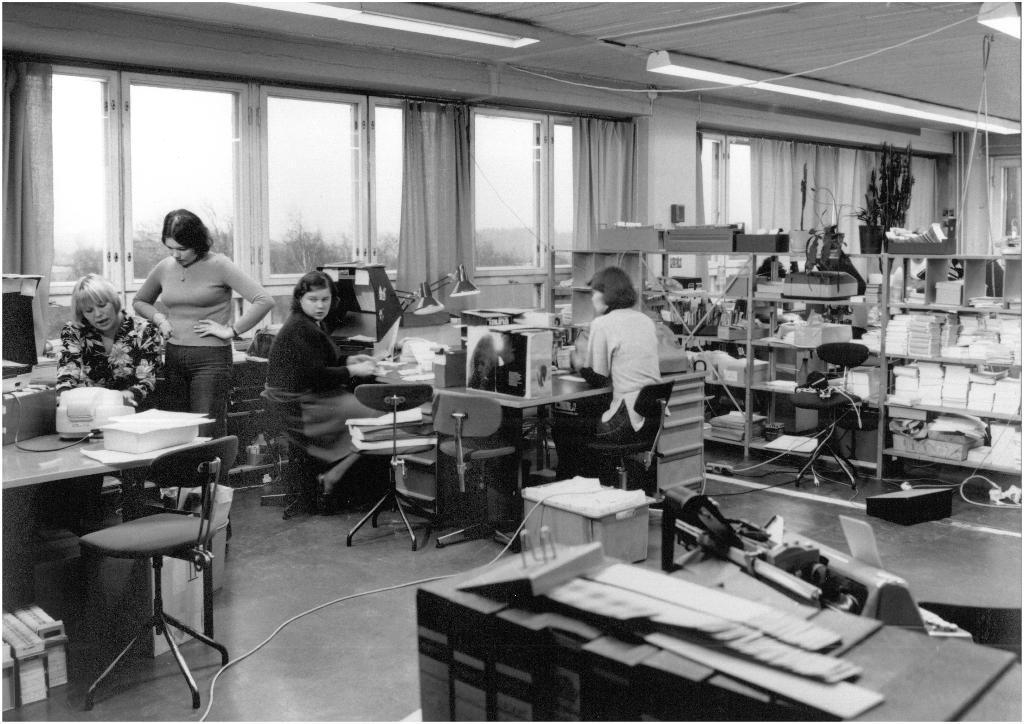In one or two sentences, can you explain what this image depicts? In this black and white image, we can see some chairs. There are three persons sitting in front of tables. There are windows in the middle of the image contains curtains. There are lights at the top of the image. There is a rack on the right side of the image contains some objects. There are boxes at the bottom of the image. 